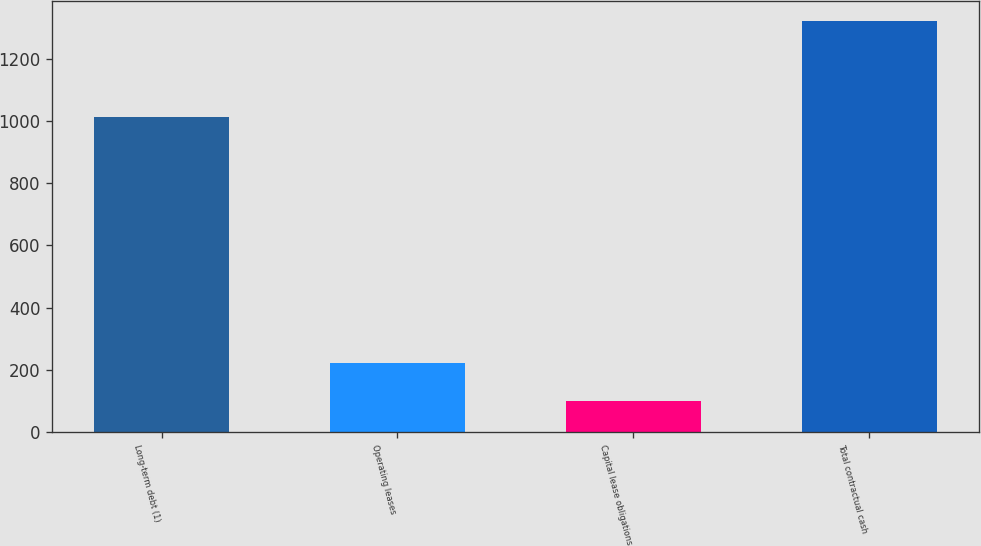Convert chart. <chart><loc_0><loc_0><loc_500><loc_500><bar_chart><fcel>Long-term debt (1)<fcel>Operating leases<fcel>Capital lease obligations<fcel>Total contractual cash<nl><fcel>1015<fcel>221.3<fcel>99<fcel>1322<nl></chart> 